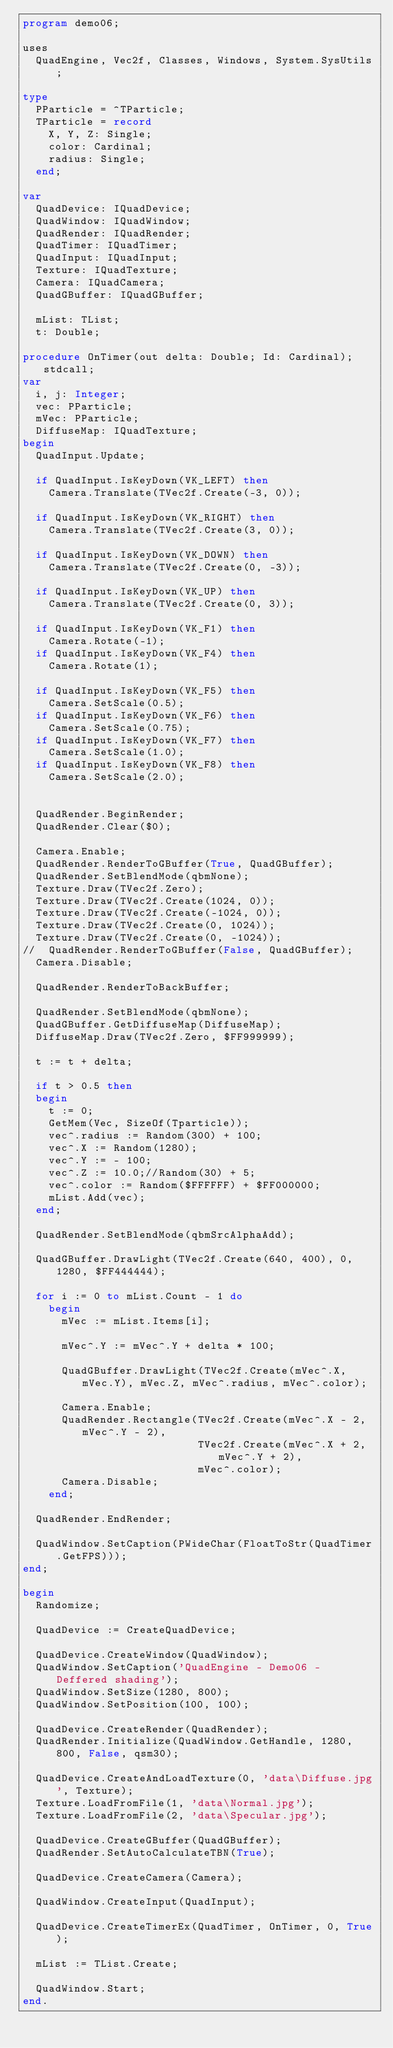<code> <loc_0><loc_0><loc_500><loc_500><_Pascal_>program demo06;

uses
  QuadEngine, Vec2f, Classes, Windows, System.SysUtils;

type
  PParticle = ^TParticle;
  TParticle = record
    X, Y, Z: Single;
    color: Cardinal;
    radius: Single;
  end;

var
  QuadDevice: IQuadDevice;
  QuadWindow: IQuadWindow;
  QuadRender: IQuadRender;
  QuadTimer: IQuadTimer;
  QuadInput: IQuadInput;
  Texture: IQuadTexture;
  Camera: IQuadCamera;
  QuadGBuffer: IQuadGBuffer;

  mList: TList;
  t: Double;

procedure OnTimer(out delta: Double; Id: Cardinal); stdcall;
var
  i, j: Integer;
  vec: PParticle;
  mVec: PParticle;
  DiffuseMap: IQuadTexture;
begin
  QuadInput.Update;

  if QuadInput.IsKeyDown(VK_LEFT) then
    Camera.Translate(TVec2f.Create(-3, 0));

  if QuadInput.IsKeyDown(VK_RIGHT) then
    Camera.Translate(TVec2f.Create(3, 0));

  if QuadInput.IsKeyDown(VK_DOWN) then
    Camera.Translate(TVec2f.Create(0, -3));

  if QuadInput.IsKeyDown(VK_UP) then
    Camera.Translate(TVec2f.Create(0, 3));

  if QuadInput.IsKeyDown(VK_F1) then
    Camera.Rotate(-1);
  if QuadInput.IsKeyDown(VK_F4) then
    Camera.Rotate(1);

  if QuadInput.IsKeyDown(VK_F5) then
    Camera.SetScale(0.5);
  if QuadInput.IsKeyDown(VK_F6) then
    Camera.SetScale(0.75);
  if QuadInput.IsKeyDown(VK_F7) then
    Camera.SetScale(1.0);
  if QuadInput.IsKeyDown(VK_F8) then
    Camera.SetScale(2.0);


  QuadRender.BeginRender;
  QuadRender.Clear($0);

  Camera.Enable;
  QuadRender.RenderToGBuffer(True, QuadGBuffer);
  QuadRender.SetBlendMode(qbmNone);
  Texture.Draw(TVec2f.Zero);
  Texture.Draw(TVec2f.Create(1024, 0));
  Texture.Draw(TVec2f.Create(-1024, 0));
  Texture.Draw(TVec2f.Create(0, 1024));
  Texture.Draw(TVec2f.Create(0, -1024));
//  QuadRender.RenderToGBuffer(False, QuadGBuffer);
  Camera.Disable;

  QuadRender.RenderToBackBuffer;

  QuadRender.SetBlendMode(qbmNone);
  QuadGBuffer.GetDiffuseMap(DiffuseMap);
  DiffuseMap.Draw(TVec2f.Zero, $FF999999);

  t := t + delta;

  if t > 0.5 then
  begin
    t := 0;
    GetMem(Vec, SizeOf(Tparticle));
    vec^.radius := Random(300) + 100;
    vec^.X := Random(1280);
    vec^.Y := - 100;
    vec^.Z := 10.0;//Random(30) + 5;
    vec^.color := Random($FFFFFF) + $FF000000;
    mList.Add(vec);
  end;

  QuadRender.SetBlendMode(qbmSrcAlphaAdd);

  QuadGBuffer.DrawLight(TVec2f.Create(640, 400), 0, 1280, $FF444444);

  for i := 0 to mList.Count - 1 do
    begin
      mVec := mList.Items[i];

      mVec^.Y := mVec^.Y + delta * 100;

      QuadGBuffer.DrawLight(TVec2f.Create(mVec^.X, mVec.Y), mVec.Z, mVec^.radius, mVec^.color);

      Camera.Enable;
      QuadRender.Rectangle(TVec2f.Create(mVec^.X - 2, mVec^.Y - 2),
                           TVec2f.Create(mVec^.X + 2, mVec^.Y + 2),
                           mVec^.color);
      Camera.Disable;
    end;

  QuadRender.EndRender;

  QuadWindow.SetCaption(PWideChar(FloatToStr(QuadTimer.GetFPS)));
end;

begin
  Randomize;

  QuadDevice := CreateQuadDevice;

  QuadDevice.CreateWindow(QuadWindow);
  QuadWindow.SetCaption('QuadEngine - Demo06 - Deffered shading');
  QuadWindow.SetSize(1280, 800);
  QuadWindow.SetPosition(100, 100);

  QuadDevice.CreateRender(QuadRender);
  QuadRender.Initialize(QuadWindow.GetHandle, 1280, 800, False, qsm30);

  QuadDevice.CreateAndLoadTexture(0, 'data\Diffuse.jpg', Texture);
  Texture.LoadFromFile(1, 'data\Normal.jpg');
  Texture.LoadFromFile(2, 'data\Specular.jpg');

  QuadDevice.CreateGBuffer(QuadGBuffer);
  QuadRender.SetAutoCalculateTBN(True);

  QuadDevice.CreateCamera(Camera);

  QuadWindow.CreateInput(QuadInput);

  QuadDevice.CreateTimerEx(QuadTimer, OnTimer, 0, True);

  mList := TList.Create;

  QuadWindow.Start;
end.
</code> 